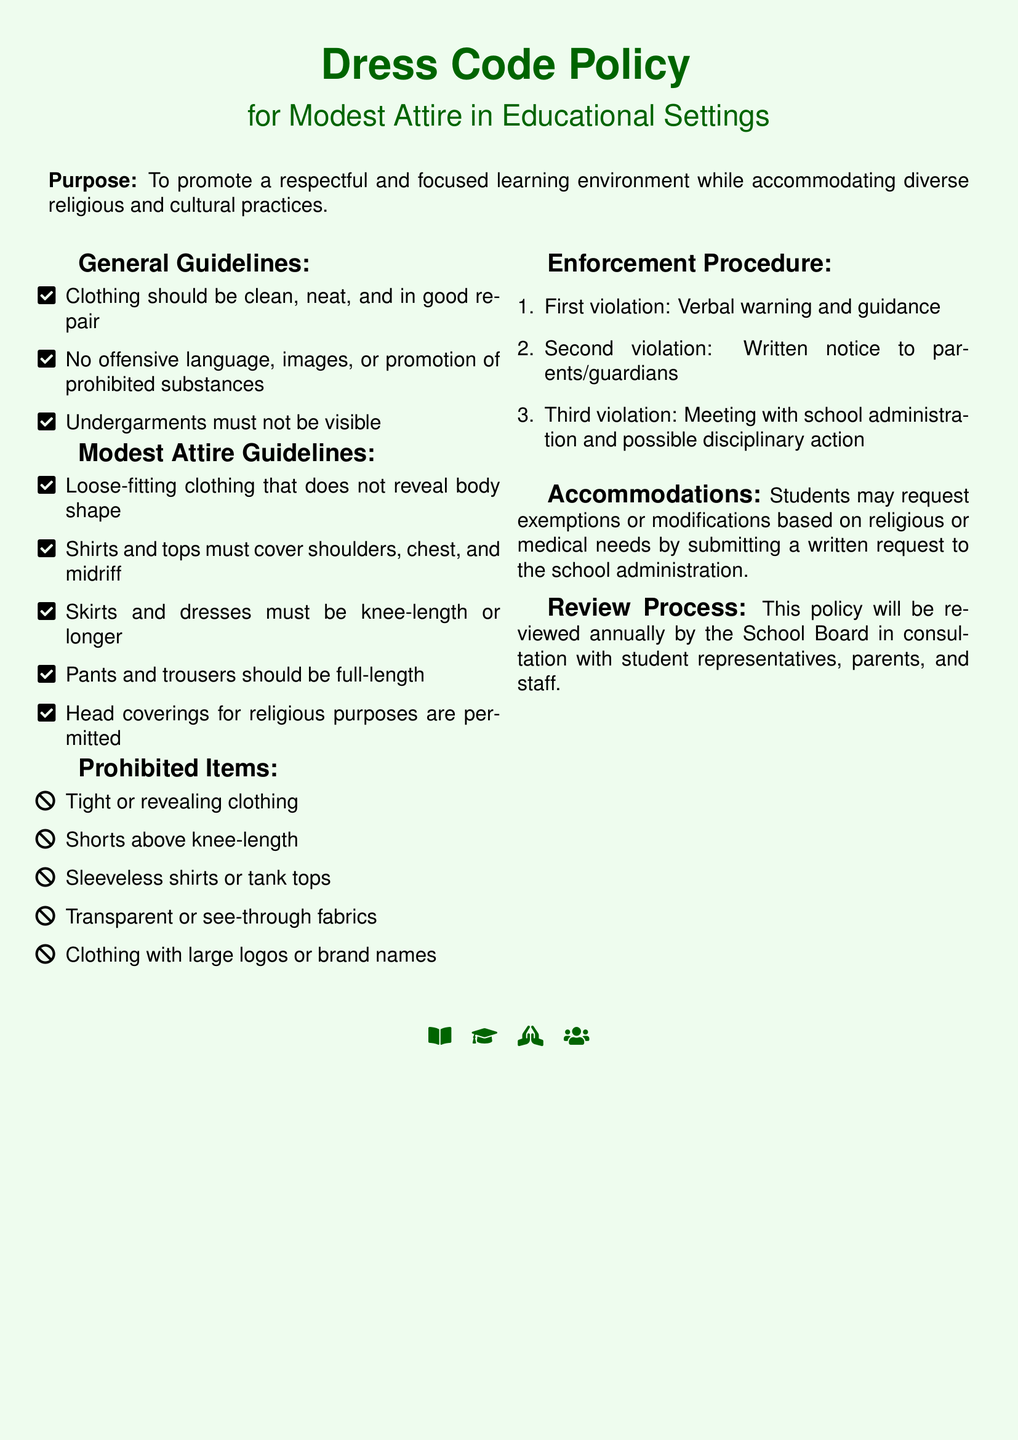What is the purpose of the dress code policy? The purpose is to promote a respectful and focused learning environment while accommodating diverse religious and cultural practices.
Answer: To promote a respectful and focused learning environment while accommodating diverse religious and cultural practices What types of clothing are prohibited? The document lists specific items that are prohibited in the dress code guidelines.
Answer: Tight or revealing clothing, Shorts above knee-length, Sleeveless shirts or tank tops, Transparent or see-through fabrics, Clothing with large logos or brand names How long should skirts and dresses be? The policy specifies the required length for skirts and dresses in the modest attire guidelines.
Answer: Knee-length or longer What will happen after the second violation of the dress code? The enforcement procedure of the policy outlines actions taken for violations.
Answer: Written notice to parents/guardians Are head coverings allowed? The modest attire guidelines mention specific allowances for religious practices.
Answer: Yes, for religious purposes How often will the policy be reviewed? The document states the frequency of the review process for the policy.
Answer: Annually What is the first step in the enforcement procedure? The document outlines a step-by-step enforcement process for violations of the dress code.
Answer: Verbal warning and guidance How are students able to request modifications? The accommodations section details how students can seek exemptions or modifications to the policy.
Answer: By submitting a written request to the school administration 